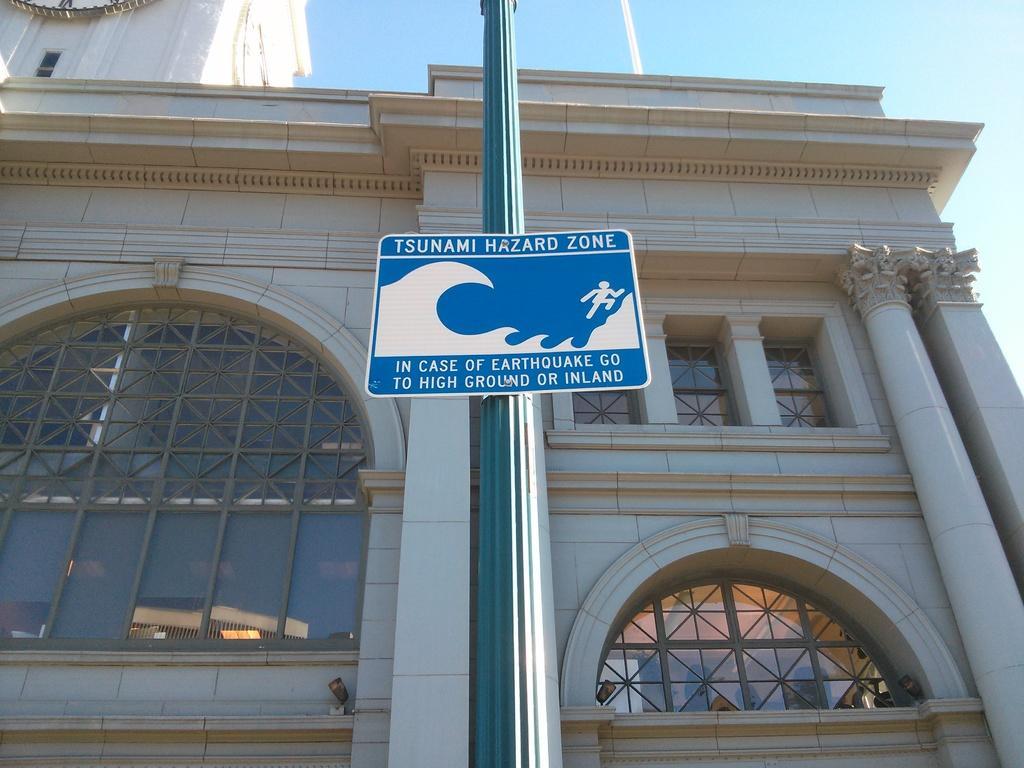Please provide a concise description of this image. In this image we can see a building, in front of the building there is a pole and a board with text and picture attached to the pole, on the glass window of the building, we can see the reflection of another building and the sky in the background. 